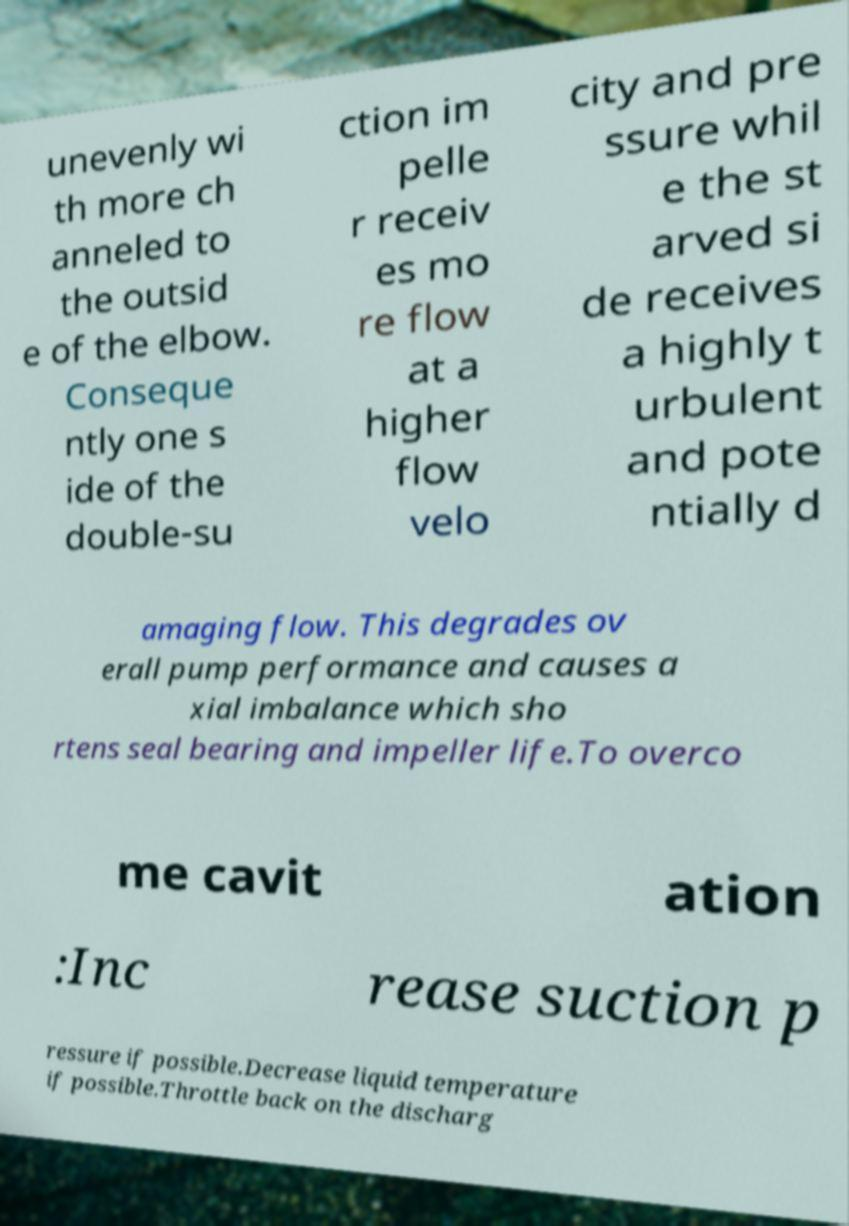Could you extract and type out the text from this image? unevenly wi th more ch anneled to the outsid e of the elbow. Conseque ntly one s ide of the double-su ction im pelle r receiv es mo re flow at a higher flow velo city and pre ssure whil e the st arved si de receives a highly t urbulent and pote ntially d amaging flow. This degrades ov erall pump performance and causes a xial imbalance which sho rtens seal bearing and impeller life.To overco me cavit ation :Inc rease suction p ressure if possible.Decrease liquid temperature if possible.Throttle back on the discharg 